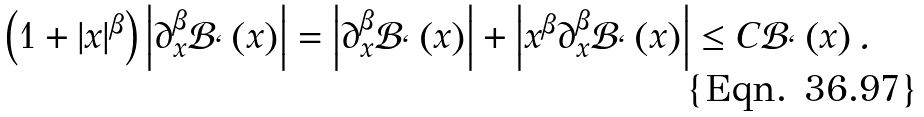<formula> <loc_0><loc_0><loc_500><loc_500>\left ( 1 + \left | x \right | ^ { \beta } \right ) \left | \partial _ { x } ^ { \beta } \mathcal { B } _ { \ell } \left ( x \right ) \right | = \left | \partial _ { x } ^ { \beta } \mathcal { B } _ { \ell } \left ( x \right ) \right | + \left | x ^ { \beta } \partial _ { x } ^ { \beta } \mathcal { B } _ { \ell } \left ( x \right ) \right | \leq C \mathcal { B } _ { \ell } \left ( x \right ) .</formula> 